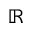<formula> <loc_0><loc_0><loc_500><loc_500>\mathbb { R }</formula> 